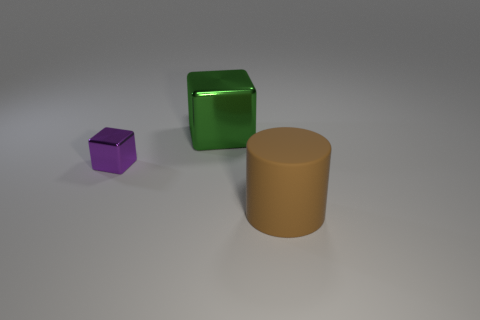Subtract all purple cylinders. Subtract all blue blocks. How many cylinders are left? 1 Subtract all brown cylinders. How many brown blocks are left? 0 Add 2 large purples. How many browns exist? 0 Subtract all large red shiny objects. Subtract all tiny objects. How many objects are left? 2 Add 1 big rubber cylinders. How many big rubber cylinders are left? 2 Add 2 gray cylinders. How many gray cylinders exist? 2 Add 3 large metallic things. How many objects exist? 6 Subtract all green blocks. How many blocks are left? 1 Subtract 0 green cylinders. How many objects are left? 3 Subtract all cylinders. How many objects are left? 2 